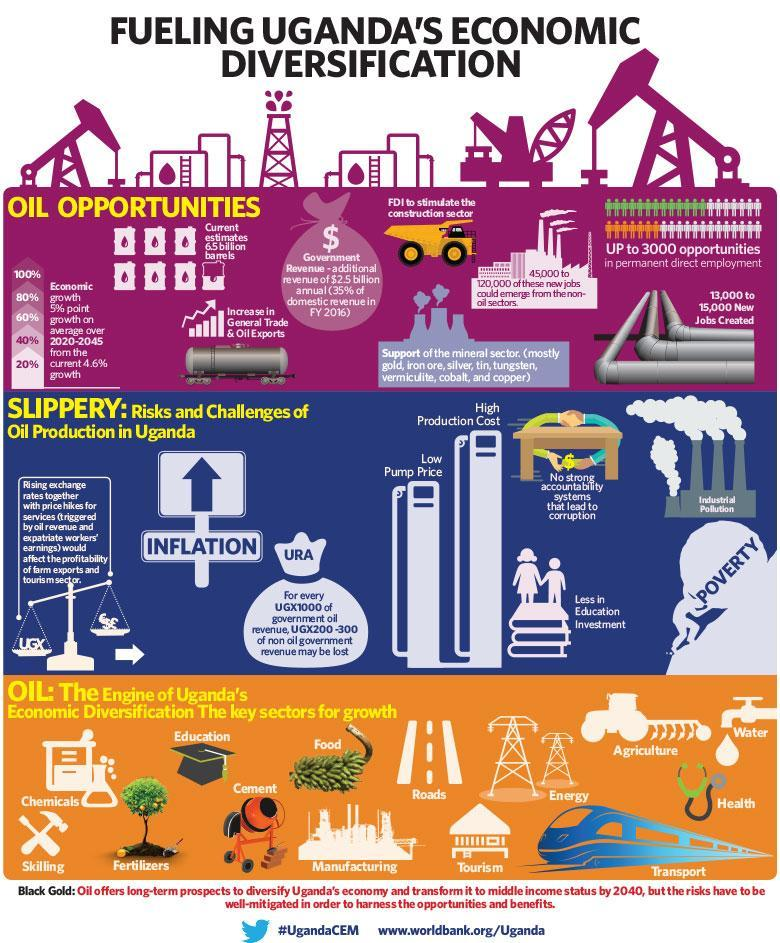Which are the first three minerals listed in the reference about the mineral sector?
Answer the question with a short phrase. gold, iron ore, silver What is the second risk shown in the image? inflation what percent of growth is expected over 2020-2045? 5% How many risks and challenges of oil production are shown in this infographic? 8 How many new jobs were created ? 13,000 to 15,000 What is listed second last among the risks and challenges? less in education investment How much is the estimated oil reserves available in Uganda? 6.5 billion barrels Which of the following sectors are listed in the key sectors for growth - food, textiles, roads, energy, music? food, roads, energy What happens due to lack of strong accountability system? corruption What is listed last among the risks and challenges? poverty 